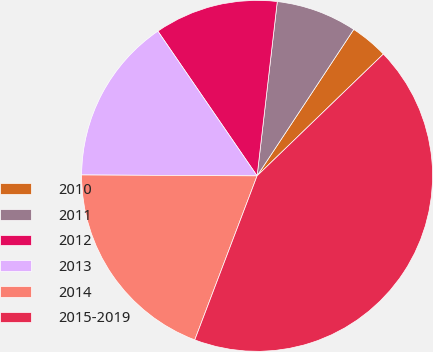Convert chart to OTSL. <chart><loc_0><loc_0><loc_500><loc_500><pie_chart><fcel>2010<fcel>2011<fcel>2012<fcel>2013<fcel>2014<fcel>2015-2019<nl><fcel>3.5%<fcel>7.45%<fcel>11.4%<fcel>15.35%<fcel>19.3%<fcel>42.99%<nl></chart> 